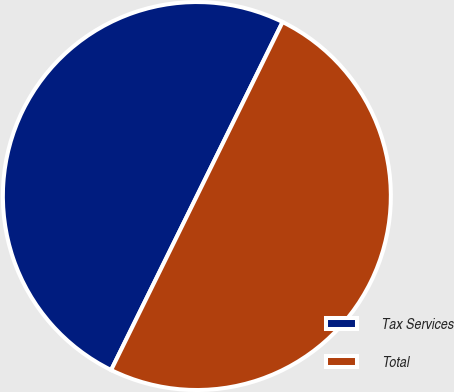Convert chart. <chart><loc_0><loc_0><loc_500><loc_500><pie_chart><fcel>Tax Services<fcel>Total<nl><fcel>50.0%<fcel>50.0%<nl></chart> 